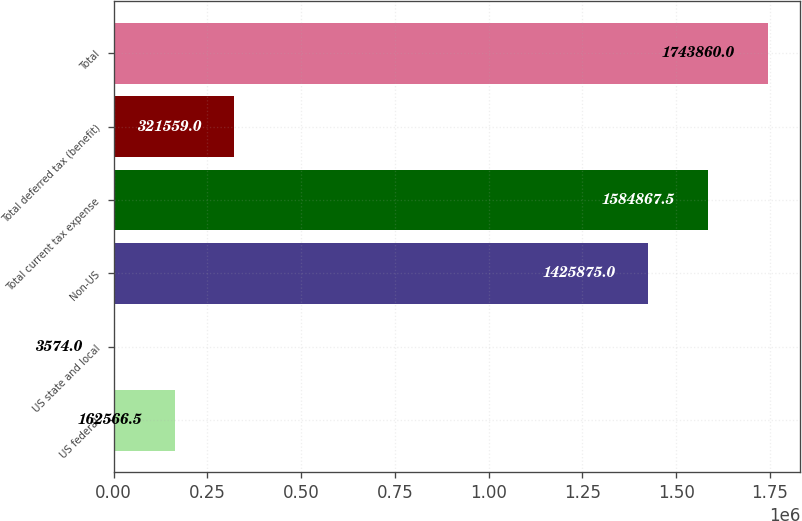Convert chart to OTSL. <chart><loc_0><loc_0><loc_500><loc_500><bar_chart><fcel>US federal<fcel>US state and local<fcel>Non-US<fcel>Total current tax expense<fcel>Total deferred tax (benefit)<fcel>Total<nl><fcel>162566<fcel>3574<fcel>1.42588e+06<fcel>1.58487e+06<fcel>321559<fcel>1.74386e+06<nl></chart> 